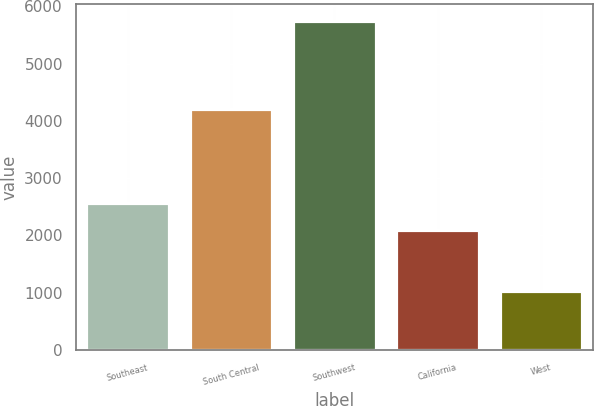Convert chart to OTSL. <chart><loc_0><loc_0><loc_500><loc_500><bar_chart><fcel>Southeast<fcel>South Central<fcel>Southwest<fcel>California<fcel>West<nl><fcel>2561.4<fcel>4213<fcel>5754<fcel>2088<fcel>1020<nl></chart> 